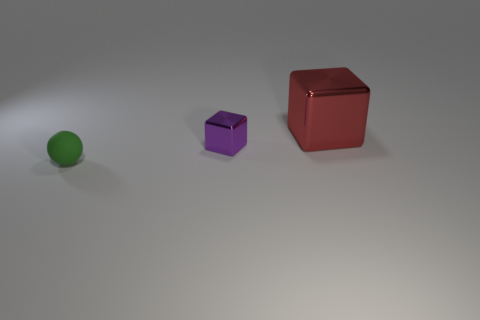How many things are either cubes that are behind the small metal block or blocks in front of the red metal block? Upon reviewing the image, I see one small purple cube behind the green sphere, which could be considered a small metal block due to its color and texture, and no cubes in front of the red metal cube. So, there is only one object that meets the criteria of the question: the purple cube behind the green sphere. 